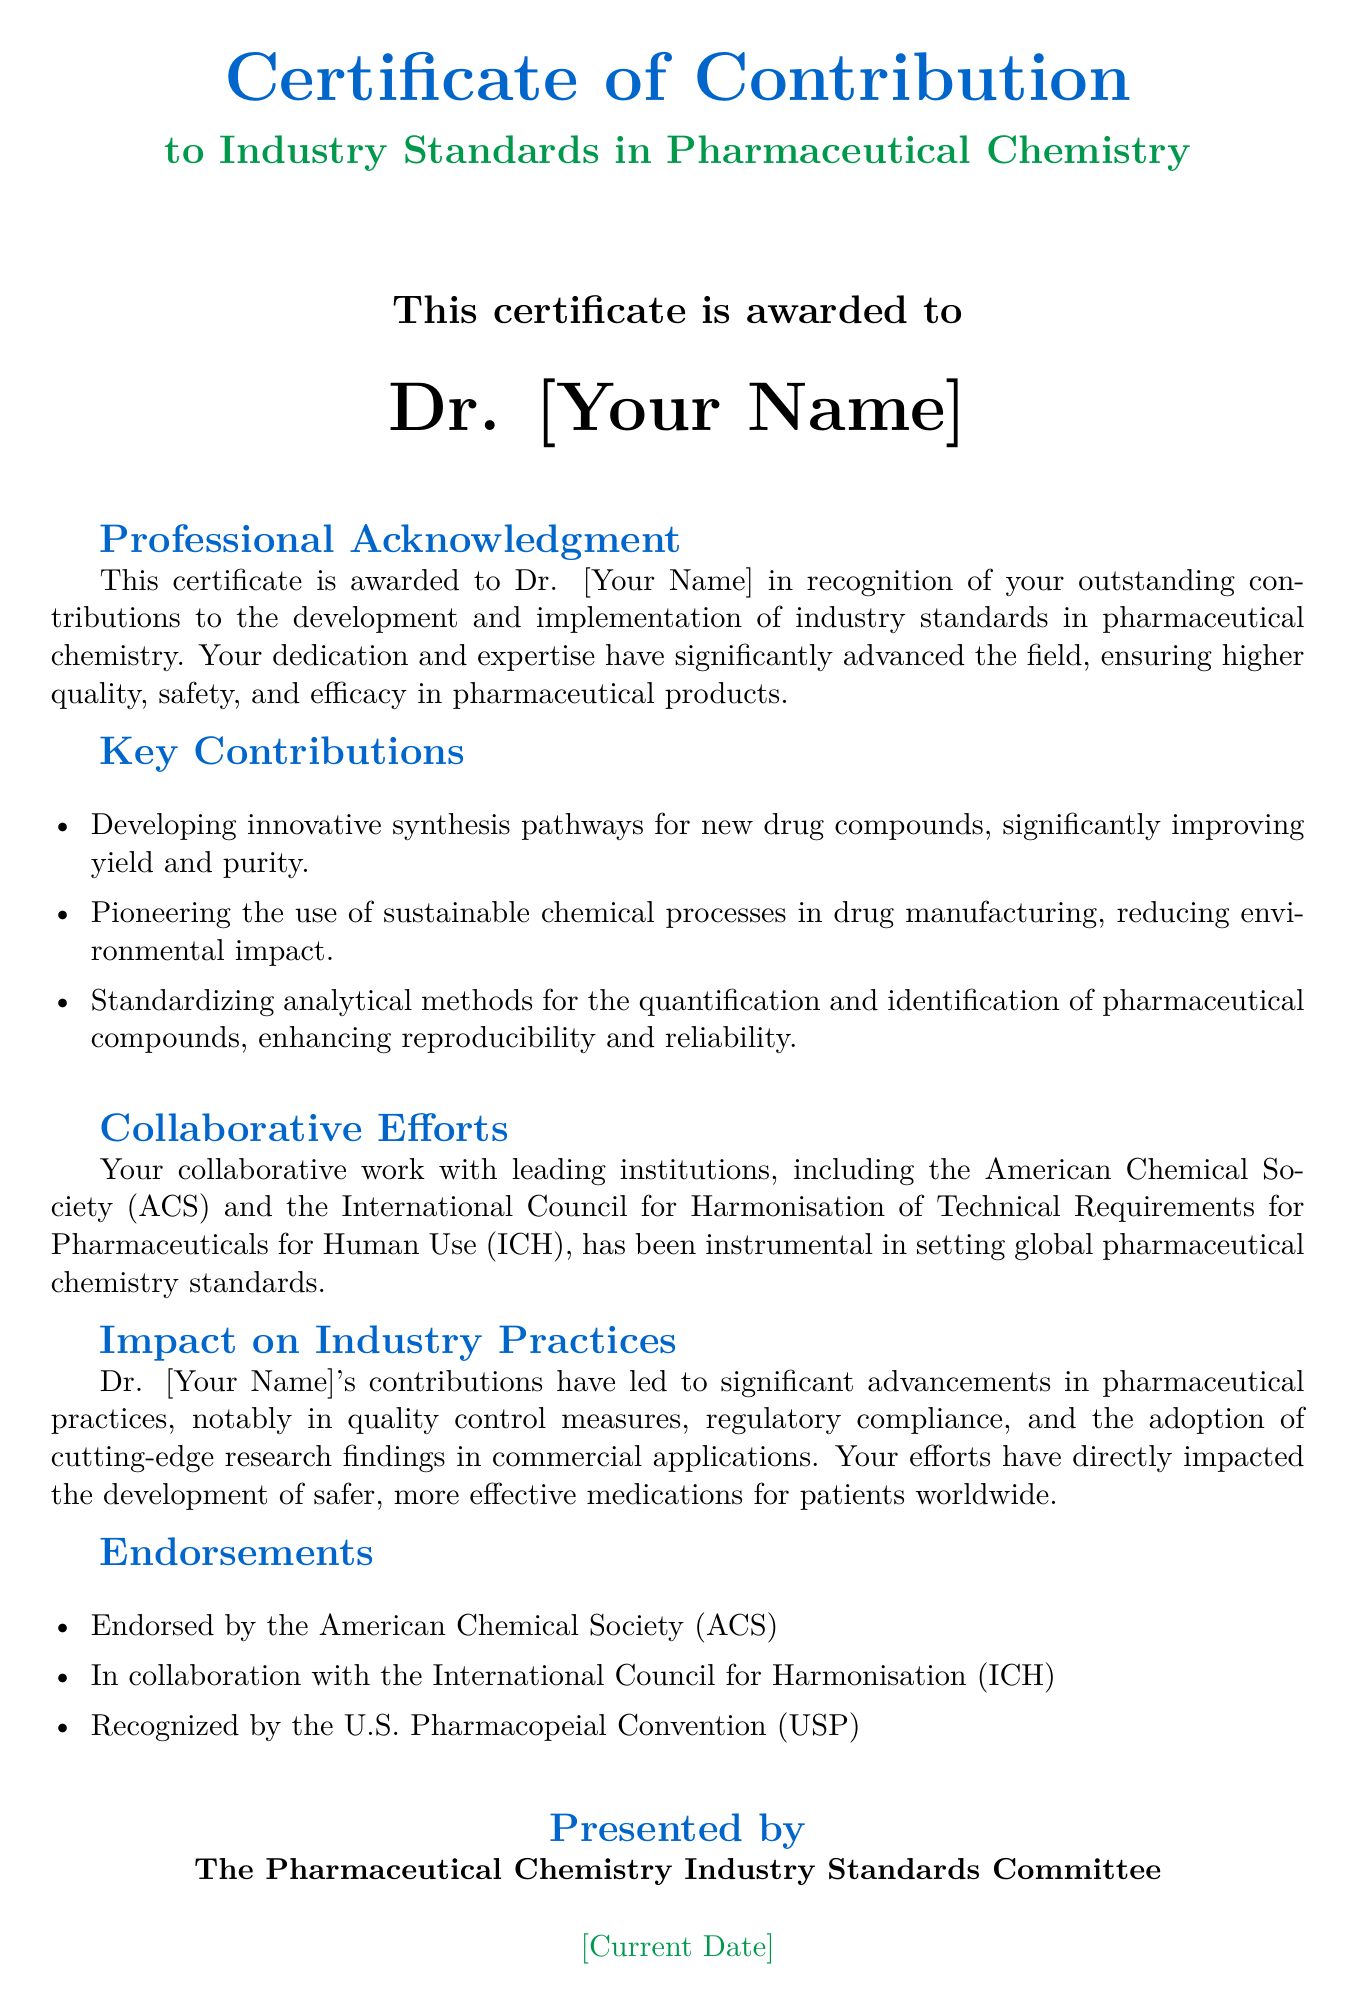What is the title of the certificate? The title of the certificate is explicitly mentioned at the top of the document as “Certificate of Contribution.”
Answer: Certificate of Contribution Who is the certificate awarded to? The document states that the certificate is awarded to Dr. [Your Name].
Answer: Dr. [Your Name] Which organization endorsed the certificate? The document lists "American Chemical Society (ACS)" as one of the endorsing organizations.
Answer: American Chemical Society (ACS) What date is mentioned at the bottom of the certificate? The document includes “[Current Date]” to indicate when the certificate was presented.
Answer: [Current Date] What is one of the key contributions highlighted in the document? The document lists several contributions, one of which is “Developing innovative synthesis pathways for new drug compounds.”
Answer: Developing innovative synthesis pathways for new drug compounds How has Dr. [Your Name]'s work impacted pharmaceutical practices? According to the text, this person’s contributions have led to "significant advancements in pharmaceutical practices."
Answer: significant advancements in pharmaceutical practices What color is used for the header text? The document uses the color defined as "chemblue" for the header text.
Answer: chemblue Which two organizations are mentioned in the context of collaborative efforts? The document mentions "American Chemical Society (ACS)" and "International Council for Harmonisation (ICH)" as collaborative partners.
Answer: American Chemical Society (ACS) and International Council for Harmonisation (ICH) What committee presented the certificate? The certificate specifies that it was presented by "The Pharmaceutical Chemistry Industry Standards Committee."
Answer: The Pharmaceutical Chemistry Industry Standards Committee 